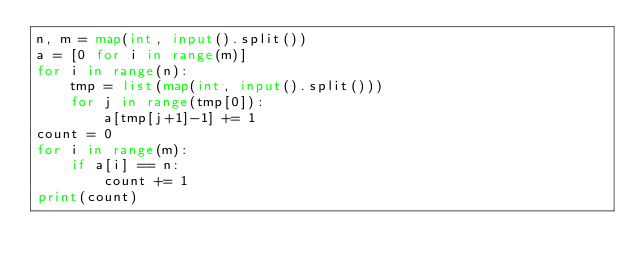Convert code to text. <code><loc_0><loc_0><loc_500><loc_500><_Python_>n, m = map(int, input().split())
a = [0 for i in range(m)]
for i in range(n):
    tmp = list(map(int, input().split()))
    for j in range(tmp[0]):
        a[tmp[j+1]-1] += 1
count = 0
for i in range(m):
    if a[i] == n:
        count += 1
print(count)</code> 